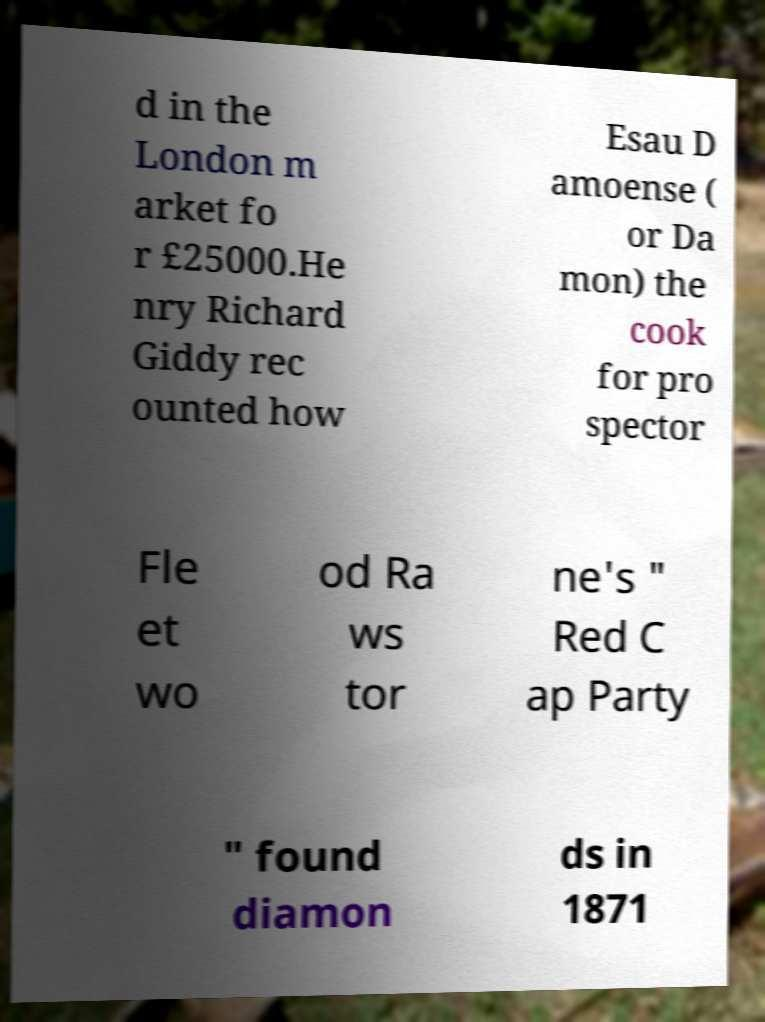What messages or text are displayed in this image? I need them in a readable, typed format. d in the London m arket fo r £25000.He nry Richard Giddy rec ounted how Esau D amoense ( or Da mon) the cook for pro spector Fle et wo od Ra ws tor ne's " Red C ap Party " found diamon ds in 1871 